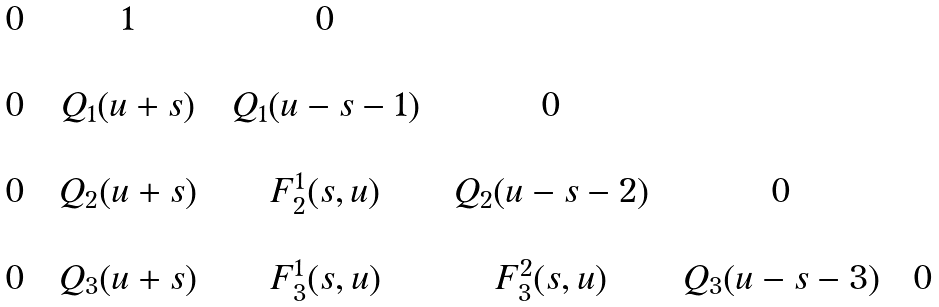<formula> <loc_0><loc_0><loc_500><loc_500>\begin{array} { c c c c c c c c c c c } 0 & & 1 & & 0 & & & & & & \\ & & & & & & & & & & \\ 0 & & Q _ { 1 } ( u + s ) & & Q _ { 1 } ( u - s - 1 ) & & 0 & & & & \\ & & & & & & & & & & \\ 0 & & Q _ { 2 } ( u + s ) & & F _ { 2 } ^ { 1 } ( s , u ) & & Q _ { 2 } ( u - s - 2 ) & & 0 & & \\ & & & & & & & & & & \\ 0 & & Q _ { 3 } ( u + s ) & & F _ { 3 } ^ { 1 } ( s , u ) & & F _ { 3 } ^ { 2 } ( s , u ) & & Q _ { 3 } ( u - s - 3 ) & & 0 \\ & & & & & & & & & & \\ \end{array}</formula> 